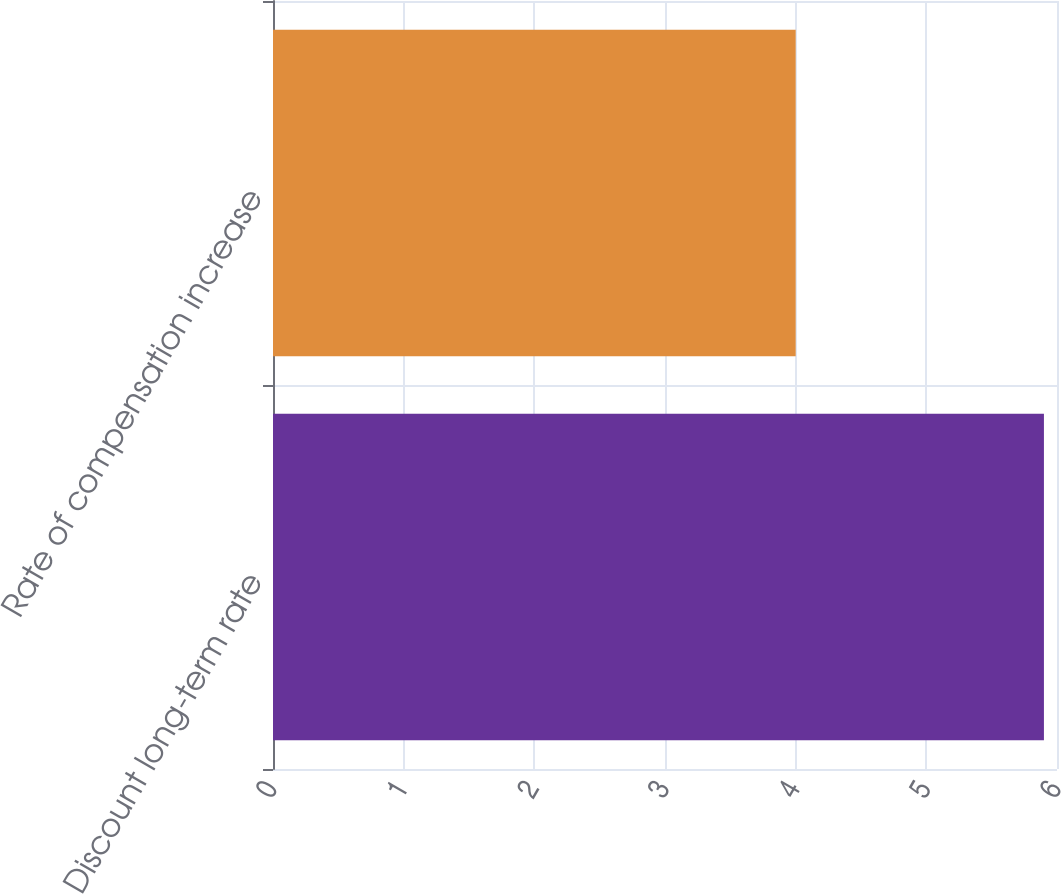<chart> <loc_0><loc_0><loc_500><loc_500><bar_chart><fcel>Discount long-term rate<fcel>Rate of compensation increase<nl><fcel>5.9<fcel>4<nl></chart> 